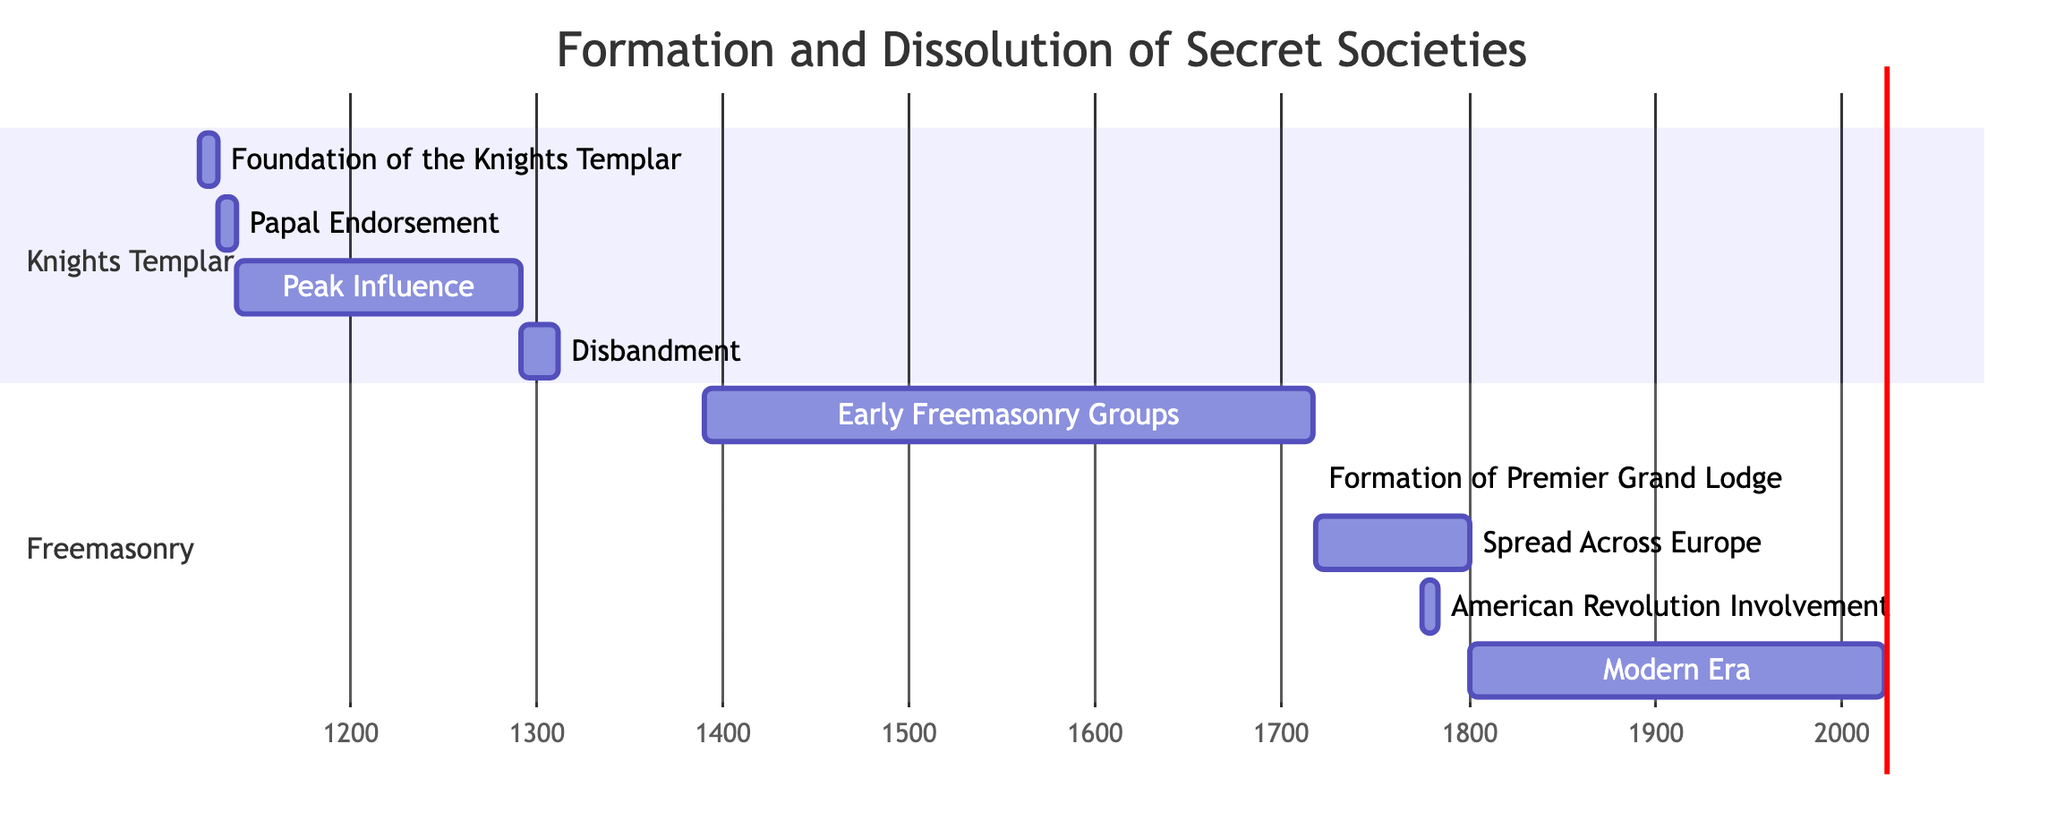What is the duration of the Knights Templar's peak influence? The Knights Templar's peak influence starts on January 1, 1139, and lasts until January 1, 1291. To calculate the duration, we subtract the start date from the end date: 1291 - 1139 = 152 years.
Answer: 152 years How many years did the Freemasonry groups exist before the formation of the Premier Grand Lodge? The Early Freemasonry Groups started in 1390 and continued until the formation of the Premier Grand Lodge on June 24, 1717. We calculate the duration by finding the difference between these two dates: 1717 - 1390 = 327 years.
Answer: 327 years Which event occurs immediately after the spread of Freemasonry across Europe? The event that follows the spread of Freemasonry across Europe, which ends on January 1, 1800, is the involvement of Freemasonry in the American Revolution, starting on April 19, 1775. The timeline shows that after 1800, the next task is the modern era.
Answer: American Revolution Involvement What is the total number of distinct tasks listed in the Gantt chart? To find the total number of distinct tasks, we simply count each task present in the chart. There are 9 tasks defined, ranging from the foundation of the Knights Templar to the modern era of Freemasonry.
Answer: 9 What is the end date of the foundation of the Knights Templar? The foundation of the Knights Templar is marked as beginning on January 1, 1119, and concludes on January 1, 1129. The end date of this task is clearly indicated as 1129-01-01.
Answer: 1129-01-01 Which task represents the disbandment of the Knights Templar? The task representing the disbandment of the Knights Templar is labeled simply as "Disbandment" and takes place from January 1, 1291, to April 3, 1312.
Answer: Disbandment What is the start date of modern-era Freemasonry? The start date of modern-era Freemasonry is clearly indicated as January 1, 1800. The chart shows this date at the beginning of the task named "Modern Era."
Answer: 1800-01-01 How long did the formation of the Premier Grand Lodge last? The formation of the Premier Grand Lodge of England took place on June 24, 1717, and ended on December 31, 1717. The duration, therefore, is approximately 6 months.
Answer: 6 months What task immediately follows the papal endorsement of the Knights Templar? The task that follows the papal endorsement of the Knights Templar is their peak influence, which begins on January 1, 1139, after the endorsement ends on January 1, 1139.
Answer: Peak Influence 